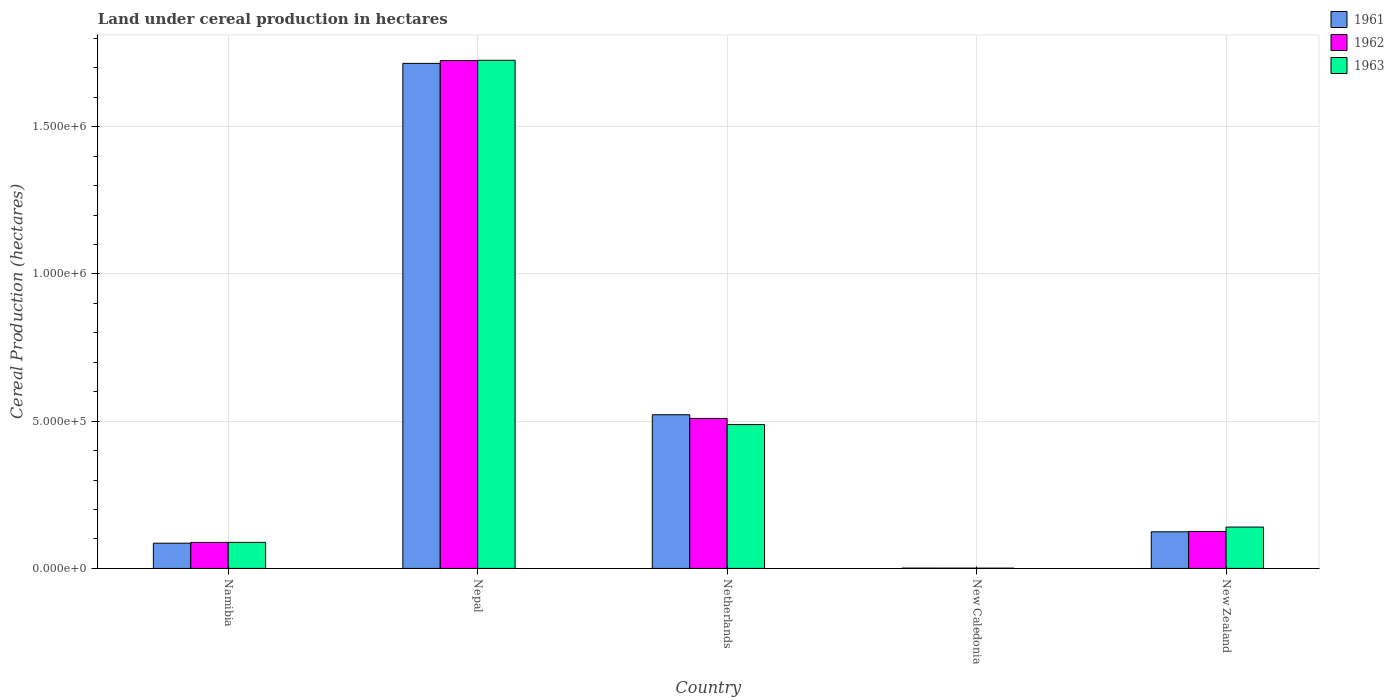How many different coloured bars are there?
Provide a succinct answer. 3. Are the number of bars per tick equal to the number of legend labels?
Offer a very short reply. Yes. How many bars are there on the 5th tick from the right?
Give a very brief answer. 3. What is the label of the 3rd group of bars from the left?
Ensure brevity in your answer.  Netherlands. In how many cases, is the number of bars for a given country not equal to the number of legend labels?
Your answer should be compact. 0. What is the land under cereal production in 1961 in Nepal?
Give a very brief answer. 1.72e+06. Across all countries, what is the maximum land under cereal production in 1963?
Your answer should be compact. 1.73e+06. Across all countries, what is the minimum land under cereal production in 1963?
Your answer should be compact. 900. In which country was the land under cereal production in 1961 maximum?
Offer a very short reply. Nepal. In which country was the land under cereal production in 1961 minimum?
Provide a short and direct response. New Caledonia. What is the total land under cereal production in 1963 in the graph?
Your answer should be compact. 2.44e+06. What is the difference between the land under cereal production in 1962 in New Caledonia and that in New Zealand?
Keep it short and to the point. -1.25e+05. What is the difference between the land under cereal production in 1963 in New Caledonia and the land under cereal production in 1961 in New Zealand?
Offer a very short reply. -1.23e+05. What is the average land under cereal production in 1961 per country?
Give a very brief answer. 4.90e+05. What is the difference between the land under cereal production of/in 1963 and land under cereal production of/in 1962 in Netherlands?
Ensure brevity in your answer.  -2.09e+04. What is the ratio of the land under cereal production in 1963 in Namibia to that in Netherlands?
Provide a short and direct response. 0.18. What is the difference between the highest and the second highest land under cereal production in 1963?
Ensure brevity in your answer.  1.59e+06. What is the difference between the highest and the lowest land under cereal production in 1962?
Offer a terse response. 1.72e+06. In how many countries, is the land under cereal production in 1962 greater than the average land under cereal production in 1962 taken over all countries?
Your answer should be compact. 2. Is the sum of the land under cereal production in 1962 in Namibia and Nepal greater than the maximum land under cereal production in 1963 across all countries?
Keep it short and to the point. Yes. What does the 1st bar from the left in Netherlands represents?
Keep it short and to the point. 1961. What does the 1st bar from the right in Nepal represents?
Provide a short and direct response. 1963. Are all the bars in the graph horizontal?
Ensure brevity in your answer.  No. How many countries are there in the graph?
Ensure brevity in your answer.  5. What is the difference between two consecutive major ticks on the Y-axis?
Make the answer very short. 5.00e+05. Where does the legend appear in the graph?
Give a very brief answer. Top right. How many legend labels are there?
Ensure brevity in your answer.  3. How are the legend labels stacked?
Keep it short and to the point. Vertical. What is the title of the graph?
Your answer should be compact. Land under cereal production in hectares. What is the label or title of the X-axis?
Your answer should be very brief. Country. What is the label or title of the Y-axis?
Ensure brevity in your answer.  Cereal Production (hectares). What is the Cereal Production (hectares) of 1961 in Namibia?
Your response must be concise. 8.56e+04. What is the Cereal Production (hectares) of 1962 in Namibia?
Provide a succinct answer. 8.84e+04. What is the Cereal Production (hectares) in 1963 in Namibia?
Give a very brief answer. 8.84e+04. What is the Cereal Production (hectares) of 1961 in Nepal?
Offer a very short reply. 1.72e+06. What is the Cereal Production (hectares) of 1962 in Nepal?
Ensure brevity in your answer.  1.72e+06. What is the Cereal Production (hectares) of 1963 in Nepal?
Make the answer very short. 1.73e+06. What is the Cereal Production (hectares) in 1961 in Netherlands?
Give a very brief answer. 5.22e+05. What is the Cereal Production (hectares) in 1962 in Netherlands?
Your answer should be compact. 5.09e+05. What is the Cereal Production (hectares) of 1963 in Netherlands?
Provide a succinct answer. 4.88e+05. What is the Cereal Production (hectares) of 1961 in New Caledonia?
Your response must be concise. 1050. What is the Cereal Production (hectares) of 1962 in New Caledonia?
Offer a very short reply. 950. What is the Cereal Production (hectares) in 1963 in New Caledonia?
Provide a short and direct response. 900. What is the Cereal Production (hectares) of 1961 in New Zealand?
Make the answer very short. 1.24e+05. What is the Cereal Production (hectares) in 1962 in New Zealand?
Give a very brief answer. 1.26e+05. What is the Cereal Production (hectares) of 1963 in New Zealand?
Keep it short and to the point. 1.40e+05. Across all countries, what is the maximum Cereal Production (hectares) of 1961?
Your response must be concise. 1.72e+06. Across all countries, what is the maximum Cereal Production (hectares) in 1962?
Make the answer very short. 1.72e+06. Across all countries, what is the maximum Cereal Production (hectares) in 1963?
Your answer should be compact. 1.73e+06. Across all countries, what is the minimum Cereal Production (hectares) of 1961?
Provide a short and direct response. 1050. Across all countries, what is the minimum Cereal Production (hectares) of 1962?
Make the answer very short. 950. Across all countries, what is the minimum Cereal Production (hectares) in 1963?
Your answer should be very brief. 900. What is the total Cereal Production (hectares) of 1961 in the graph?
Your response must be concise. 2.45e+06. What is the total Cereal Production (hectares) in 1962 in the graph?
Offer a very short reply. 2.45e+06. What is the total Cereal Production (hectares) in 1963 in the graph?
Give a very brief answer. 2.44e+06. What is the difference between the Cereal Production (hectares) in 1961 in Namibia and that in Nepal?
Ensure brevity in your answer.  -1.63e+06. What is the difference between the Cereal Production (hectares) in 1962 in Namibia and that in Nepal?
Offer a terse response. -1.64e+06. What is the difference between the Cereal Production (hectares) of 1963 in Namibia and that in Nepal?
Your response must be concise. -1.64e+06. What is the difference between the Cereal Production (hectares) of 1961 in Namibia and that in Netherlands?
Your response must be concise. -4.36e+05. What is the difference between the Cereal Production (hectares) in 1962 in Namibia and that in Netherlands?
Your answer should be compact. -4.21e+05. What is the difference between the Cereal Production (hectares) of 1963 in Namibia and that in Netherlands?
Your answer should be very brief. -4.00e+05. What is the difference between the Cereal Production (hectares) of 1961 in Namibia and that in New Caledonia?
Ensure brevity in your answer.  8.46e+04. What is the difference between the Cereal Production (hectares) of 1962 in Namibia and that in New Caledonia?
Your response must be concise. 8.74e+04. What is the difference between the Cereal Production (hectares) in 1963 in Namibia and that in New Caledonia?
Your answer should be very brief. 8.76e+04. What is the difference between the Cereal Production (hectares) in 1961 in Namibia and that in New Zealand?
Offer a very short reply. -3.88e+04. What is the difference between the Cereal Production (hectares) in 1962 in Namibia and that in New Zealand?
Give a very brief answer. -3.72e+04. What is the difference between the Cereal Production (hectares) in 1963 in Namibia and that in New Zealand?
Give a very brief answer. -5.19e+04. What is the difference between the Cereal Production (hectares) in 1961 in Nepal and that in Netherlands?
Your answer should be compact. 1.19e+06. What is the difference between the Cereal Production (hectares) of 1962 in Nepal and that in Netherlands?
Offer a very short reply. 1.22e+06. What is the difference between the Cereal Production (hectares) in 1963 in Nepal and that in Netherlands?
Keep it short and to the point. 1.24e+06. What is the difference between the Cereal Production (hectares) in 1961 in Nepal and that in New Caledonia?
Your answer should be compact. 1.71e+06. What is the difference between the Cereal Production (hectares) in 1962 in Nepal and that in New Caledonia?
Ensure brevity in your answer.  1.72e+06. What is the difference between the Cereal Production (hectares) of 1963 in Nepal and that in New Caledonia?
Keep it short and to the point. 1.72e+06. What is the difference between the Cereal Production (hectares) in 1961 in Nepal and that in New Zealand?
Offer a very short reply. 1.59e+06. What is the difference between the Cereal Production (hectares) in 1962 in Nepal and that in New Zealand?
Provide a succinct answer. 1.60e+06. What is the difference between the Cereal Production (hectares) of 1963 in Nepal and that in New Zealand?
Your response must be concise. 1.59e+06. What is the difference between the Cereal Production (hectares) in 1961 in Netherlands and that in New Caledonia?
Provide a succinct answer. 5.21e+05. What is the difference between the Cereal Production (hectares) in 1962 in Netherlands and that in New Caledonia?
Your response must be concise. 5.08e+05. What is the difference between the Cereal Production (hectares) of 1963 in Netherlands and that in New Caledonia?
Your response must be concise. 4.87e+05. What is the difference between the Cereal Production (hectares) in 1961 in Netherlands and that in New Zealand?
Ensure brevity in your answer.  3.97e+05. What is the difference between the Cereal Production (hectares) of 1962 in Netherlands and that in New Zealand?
Offer a very short reply. 3.84e+05. What is the difference between the Cereal Production (hectares) in 1963 in Netherlands and that in New Zealand?
Offer a very short reply. 3.48e+05. What is the difference between the Cereal Production (hectares) in 1961 in New Caledonia and that in New Zealand?
Keep it short and to the point. -1.23e+05. What is the difference between the Cereal Production (hectares) in 1962 in New Caledonia and that in New Zealand?
Offer a terse response. -1.25e+05. What is the difference between the Cereal Production (hectares) in 1963 in New Caledonia and that in New Zealand?
Your answer should be compact. -1.39e+05. What is the difference between the Cereal Production (hectares) of 1961 in Namibia and the Cereal Production (hectares) of 1962 in Nepal?
Make the answer very short. -1.64e+06. What is the difference between the Cereal Production (hectares) of 1961 in Namibia and the Cereal Production (hectares) of 1963 in Nepal?
Your answer should be very brief. -1.64e+06. What is the difference between the Cereal Production (hectares) of 1962 in Namibia and the Cereal Production (hectares) of 1963 in Nepal?
Ensure brevity in your answer.  -1.64e+06. What is the difference between the Cereal Production (hectares) in 1961 in Namibia and the Cereal Production (hectares) in 1962 in Netherlands?
Your answer should be compact. -4.24e+05. What is the difference between the Cereal Production (hectares) of 1961 in Namibia and the Cereal Production (hectares) of 1963 in Netherlands?
Ensure brevity in your answer.  -4.03e+05. What is the difference between the Cereal Production (hectares) in 1962 in Namibia and the Cereal Production (hectares) in 1963 in Netherlands?
Give a very brief answer. -4.00e+05. What is the difference between the Cereal Production (hectares) in 1961 in Namibia and the Cereal Production (hectares) in 1962 in New Caledonia?
Provide a succinct answer. 8.46e+04. What is the difference between the Cereal Production (hectares) in 1961 in Namibia and the Cereal Production (hectares) in 1963 in New Caledonia?
Your answer should be compact. 8.47e+04. What is the difference between the Cereal Production (hectares) of 1962 in Namibia and the Cereal Production (hectares) of 1963 in New Caledonia?
Provide a succinct answer. 8.75e+04. What is the difference between the Cereal Production (hectares) of 1961 in Namibia and the Cereal Production (hectares) of 1962 in New Zealand?
Keep it short and to the point. -4.00e+04. What is the difference between the Cereal Production (hectares) in 1961 in Namibia and the Cereal Production (hectares) in 1963 in New Zealand?
Make the answer very short. -5.48e+04. What is the difference between the Cereal Production (hectares) in 1962 in Namibia and the Cereal Production (hectares) in 1963 in New Zealand?
Give a very brief answer. -5.20e+04. What is the difference between the Cereal Production (hectares) in 1961 in Nepal and the Cereal Production (hectares) in 1962 in Netherlands?
Offer a very short reply. 1.21e+06. What is the difference between the Cereal Production (hectares) in 1961 in Nepal and the Cereal Production (hectares) in 1963 in Netherlands?
Offer a very short reply. 1.23e+06. What is the difference between the Cereal Production (hectares) in 1962 in Nepal and the Cereal Production (hectares) in 1963 in Netherlands?
Provide a short and direct response. 1.24e+06. What is the difference between the Cereal Production (hectares) in 1961 in Nepal and the Cereal Production (hectares) in 1962 in New Caledonia?
Offer a very short reply. 1.71e+06. What is the difference between the Cereal Production (hectares) in 1961 in Nepal and the Cereal Production (hectares) in 1963 in New Caledonia?
Provide a short and direct response. 1.71e+06. What is the difference between the Cereal Production (hectares) of 1962 in Nepal and the Cereal Production (hectares) of 1963 in New Caledonia?
Offer a terse response. 1.72e+06. What is the difference between the Cereal Production (hectares) of 1961 in Nepal and the Cereal Production (hectares) of 1962 in New Zealand?
Offer a very short reply. 1.59e+06. What is the difference between the Cereal Production (hectares) of 1961 in Nepal and the Cereal Production (hectares) of 1963 in New Zealand?
Make the answer very short. 1.57e+06. What is the difference between the Cereal Production (hectares) in 1962 in Nepal and the Cereal Production (hectares) in 1963 in New Zealand?
Offer a terse response. 1.58e+06. What is the difference between the Cereal Production (hectares) in 1961 in Netherlands and the Cereal Production (hectares) in 1962 in New Caledonia?
Offer a very short reply. 5.21e+05. What is the difference between the Cereal Production (hectares) of 1961 in Netherlands and the Cereal Production (hectares) of 1963 in New Caledonia?
Offer a terse response. 5.21e+05. What is the difference between the Cereal Production (hectares) of 1962 in Netherlands and the Cereal Production (hectares) of 1963 in New Caledonia?
Provide a succinct answer. 5.08e+05. What is the difference between the Cereal Production (hectares) in 1961 in Netherlands and the Cereal Production (hectares) in 1962 in New Zealand?
Your response must be concise. 3.96e+05. What is the difference between the Cereal Production (hectares) in 1961 in Netherlands and the Cereal Production (hectares) in 1963 in New Zealand?
Keep it short and to the point. 3.81e+05. What is the difference between the Cereal Production (hectares) in 1962 in Netherlands and the Cereal Production (hectares) in 1963 in New Zealand?
Provide a succinct answer. 3.69e+05. What is the difference between the Cereal Production (hectares) in 1961 in New Caledonia and the Cereal Production (hectares) in 1962 in New Zealand?
Your answer should be compact. -1.25e+05. What is the difference between the Cereal Production (hectares) in 1961 in New Caledonia and the Cereal Production (hectares) in 1963 in New Zealand?
Your response must be concise. -1.39e+05. What is the difference between the Cereal Production (hectares) in 1962 in New Caledonia and the Cereal Production (hectares) in 1963 in New Zealand?
Keep it short and to the point. -1.39e+05. What is the average Cereal Production (hectares) of 1961 per country?
Your answer should be compact. 4.90e+05. What is the average Cereal Production (hectares) of 1962 per country?
Your response must be concise. 4.90e+05. What is the average Cereal Production (hectares) of 1963 per country?
Your answer should be compact. 4.89e+05. What is the difference between the Cereal Production (hectares) in 1961 and Cereal Production (hectares) in 1962 in Namibia?
Make the answer very short. -2800. What is the difference between the Cereal Production (hectares) of 1961 and Cereal Production (hectares) of 1963 in Namibia?
Your response must be concise. -2850. What is the difference between the Cereal Production (hectares) of 1961 and Cereal Production (hectares) of 1962 in Nepal?
Make the answer very short. -9500. What is the difference between the Cereal Production (hectares) of 1961 and Cereal Production (hectares) of 1963 in Nepal?
Provide a short and direct response. -1.05e+04. What is the difference between the Cereal Production (hectares) of 1962 and Cereal Production (hectares) of 1963 in Nepal?
Ensure brevity in your answer.  -1000. What is the difference between the Cereal Production (hectares) in 1961 and Cereal Production (hectares) in 1962 in Netherlands?
Your answer should be compact. 1.25e+04. What is the difference between the Cereal Production (hectares) in 1961 and Cereal Production (hectares) in 1963 in Netherlands?
Your answer should be compact. 3.34e+04. What is the difference between the Cereal Production (hectares) in 1962 and Cereal Production (hectares) in 1963 in Netherlands?
Offer a terse response. 2.09e+04. What is the difference between the Cereal Production (hectares) of 1961 and Cereal Production (hectares) of 1963 in New Caledonia?
Your answer should be very brief. 150. What is the difference between the Cereal Production (hectares) of 1961 and Cereal Production (hectares) of 1962 in New Zealand?
Provide a succinct answer. -1208. What is the difference between the Cereal Production (hectares) of 1961 and Cereal Production (hectares) of 1963 in New Zealand?
Ensure brevity in your answer.  -1.60e+04. What is the difference between the Cereal Production (hectares) in 1962 and Cereal Production (hectares) in 1963 in New Zealand?
Provide a short and direct response. -1.48e+04. What is the ratio of the Cereal Production (hectares) of 1961 in Namibia to that in Nepal?
Keep it short and to the point. 0.05. What is the ratio of the Cereal Production (hectares) of 1962 in Namibia to that in Nepal?
Your answer should be very brief. 0.05. What is the ratio of the Cereal Production (hectares) of 1963 in Namibia to that in Nepal?
Your response must be concise. 0.05. What is the ratio of the Cereal Production (hectares) of 1961 in Namibia to that in Netherlands?
Your response must be concise. 0.16. What is the ratio of the Cereal Production (hectares) in 1962 in Namibia to that in Netherlands?
Give a very brief answer. 0.17. What is the ratio of the Cereal Production (hectares) of 1963 in Namibia to that in Netherlands?
Provide a short and direct response. 0.18. What is the ratio of the Cereal Production (hectares) in 1961 in Namibia to that in New Caledonia?
Make the answer very short. 81.52. What is the ratio of the Cereal Production (hectares) of 1962 in Namibia to that in New Caledonia?
Make the answer very short. 93.05. What is the ratio of the Cereal Production (hectares) in 1963 in Namibia to that in New Caledonia?
Your response must be concise. 98.28. What is the ratio of the Cereal Production (hectares) of 1961 in Namibia to that in New Zealand?
Your answer should be very brief. 0.69. What is the ratio of the Cereal Production (hectares) of 1962 in Namibia to that in New Zealand?
Provide a short and direct response. 0.7. What is the ratio of the Cereal Production (hectares) of 1963 in Namibia to that in New Zealand?
Provide a short and direct response. 0.63. What is the ratio of the Cereal Production (hectares) in 1961 in Nepal to that in Netherlands?
Keep it short and to the point. 3.29. What is the ratio of the Cereal Production (hectares) in 1962 in Nepal to that in Netherlands?
Your response must be concise. 3.39. What is the ratio of the Cereal Production (hectares) in 1963 in Nepal to that in Netherlands?
Give a very brief answer. 3.53. What is the ratio of the Cereal Production (hectares) in 1961 in Nepal to that in New Caledonia?
Give a very brief answer. 1633.33. What is the ratio of the Cereal Production (hectares) of 1962 in Nepal to that in New Caledonia?
Provide a short and direct response. 1815.26. What is the ratio of the Cereal Production (hectares) of 1963 in Nepal to that in New Caledonia?
Offer a very short reply. 1917.22. What is the ratio of the Cereal Production (hectares) of 1961 in Nepal to that in New Zealand?
Your answer should be compact. 13.79. What is the ratio of the Cereal Production (hectares) in 1962 in Nepal to that in New Zealand?
Offer a terse response. 13.73. What is the ratio of the Cereal Production (hectares) in 1963 in Nepal to that in New Zealand?
Offer a very short reply. 12.29. What is the ratio of the Cereal Production (hectares) of 1961 in Netherlands to that in New Caledonia?
Make the answer very short. 496.92. What is the ratio of the Cereal Production (hectares) of 1962 in Netherlands to that in New Caledonia?
Your answer should be very brief. 536.09. What is the ratio of the Cereal Production (hectares) in 1963 in Netherlands to that in New Caledonia?
Provide a short and direct response. 542.64. What is the ratio of the Cereal Production (hectares) of 1961 in Netherlands to that in New Zealand?
Make the answer very short. 4.2. What is the ratio of the Cereal Production (hectares) in 1962 in Netherlands to that in New Zealand?
Offer a terse response. 4.06. What is the ratio of the Cereal Production (hectares) in 1963 in Netherlands to that in New Zealand?
Give a very brief answer. 3.48. What is the ratio of the Cereal Production (hectares) in 1961 in New Caledonia to that in New Zealand?
Ensure brevity in your answer.  0.01. What is the ratio of the Cereal Production (hectares) of 1962 in New Caledonia to that in New Zealand?
Your response must be concise. 0.01. What is the ratio of the Cereal Production (hectares) in 1963 in New Caledonia to that in New Zealand?
Keep it short and to the point. 0.01. What is the difference between the highest and the second highest Cereal Production (hectares) in 1961?
Your answer should be compact. 1.19e+06. What is the difference between the highest and the second highest Cereal Production (hectares) of 1962?
Offer a very short reply. 1.22e+06. What is the difference between the highest and the second highest Cereal Production (hectares) in 1963?
Your answer should be very brief. 1.24e+06. What is the difference between the highest and the lowest Cereal Production (hectares) in 1961?
Your answer should be compact. 1.71e+06. What is the difference between the highest and the lowest Cereal Production (hectares) in 1962?
Keep it short and to the point. 1.72e+06. What is the difference between the highest and the lowest Cereal Production (hectares) in 1963?
Make the answer very short. 1.72e+06. 